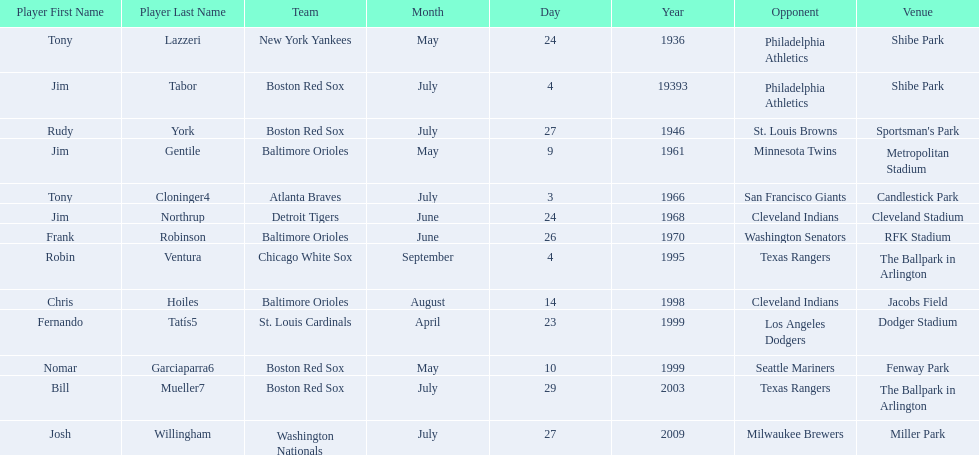What was the name of the last person to accomplish this up to date? Josh Willingham. 